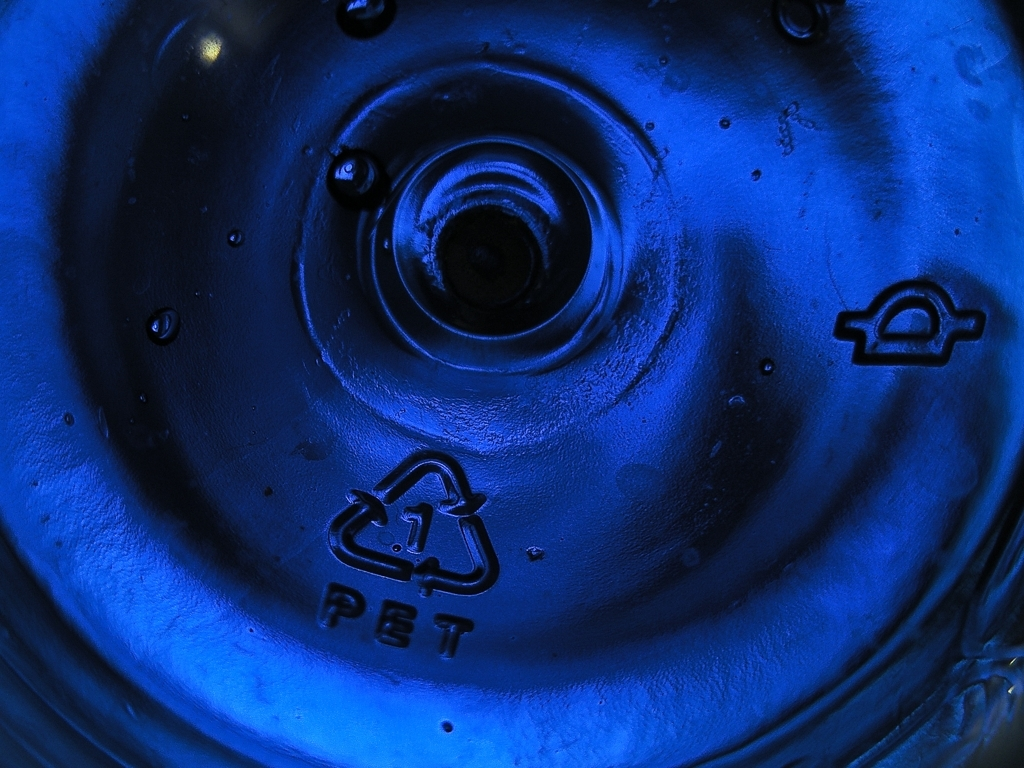Can you tell me what material the item in the image is made from? The object in the image appears to be made of polyethylene terephthalate, commonly known as PET, which is a type of plastic frequently used in packaging, including bottles and containers. 